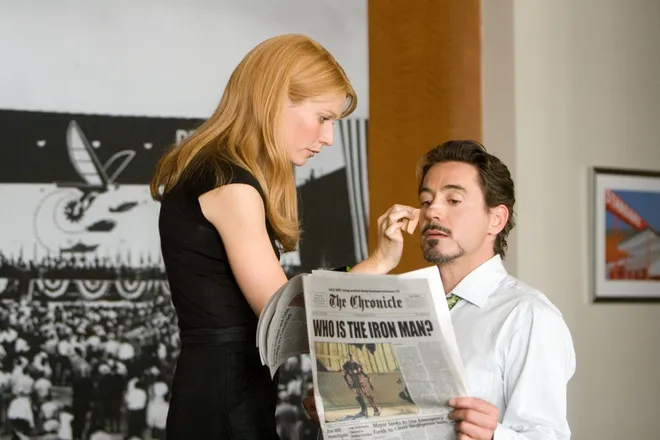Can you describe the setting of this scene more precisely? This scene is set in a tastefully decorated room that suggests minimalism and sophistication. There's a large artwork in the background that appears reminiscent of airplane blueprints, hinting at Stark's background in engineering and innovation. The overall ambiance is quiet and private, fitting for a personal and potentially confidential conversation. 